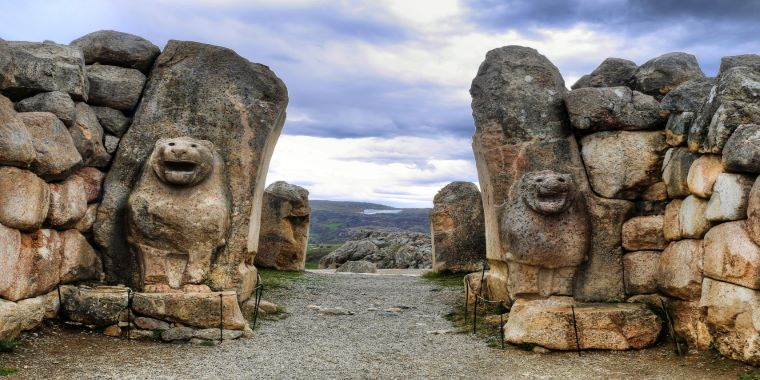Exploring the social structure of the Hittite society as evidenced by the Lion Gate's design. The grandeur and intricacy of the Lion Gate reveal much about the Hittite social structure. The centrality and magnificence of the gate underscore its importance, likely reserved for the elite – kings, priests, and high-ranking officials. The presence of lion sculptures, symbols of royalty and divine protection, indicates a hierarchical society with clear distinctions of power and spirituality. The meticulous construction and artistic flourish suggest a skilled labor force and a society that valued craftsmanship and aesthetics. Through the Lion Gate, one can infer a complex, stratified society where architecture served not just functional, but ceremonial and symbolic purposes. 